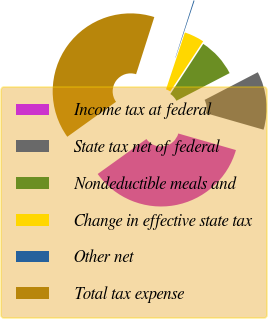<chart> <loc_0><loc_0><loc_500><loc_500><pie_chart><fcel>Income tax at federal<fcel>State tax net of federal<fcel>Nondeductible meals and<fcel>Change in effective state tax<fcel>Other net<fcel>Total tax expense<nl><fcel>35.64%<fcel>12.08%<fcel>8.12%<fcel>4.15%<fcel>0.19%<fcel>39.82%<nl></chart> 